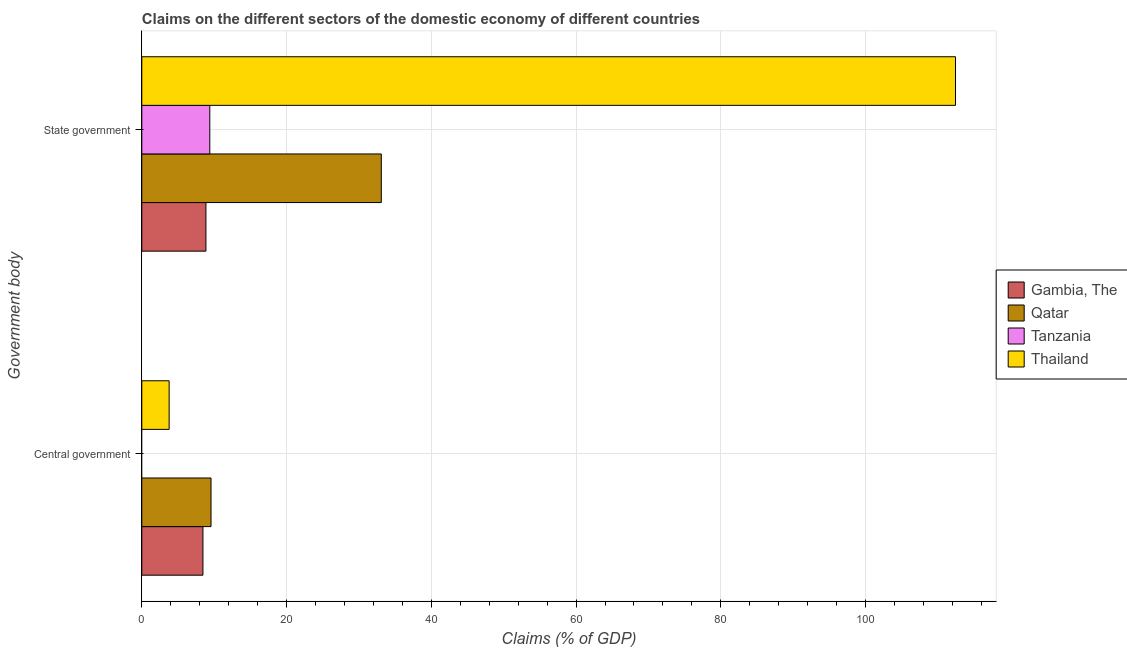Are the number of bars per tick equal to the number of legend labels?
Keep it short and to the point. No. How many bars are there on the 1st tick from the top?
Your answer should be compact. 4. What is the label of the 1st group of bars from the top?
Keep it short and to the point. State government. What is the claims on state government in Tanzania?
Provide a short and direct response. 9.4. Across all countries, what is the maximum claims on central government?
Make the answer very short. 9.56. Across all countries, what is the minimum claims on state government?
Ensure brevity in your answer.  8.86. In which country was the claims on state government maximum?
Your answer should be compact. Thailand. What is the total claims on central government in the graph?
Offer a very short reply. 21.79. What is the difference between the claims on state government in Tanzania and that in Qatar?
Your response must be concise. -23.7. What is the difference between the claims on state government in Tanzania and the claims on central government in Thailand?
Keep it short and to the point. 5.62. What is the average claims on central government per country?
Your answer should be compact. 5.45. What is the difference between the claims on state government and claims on central government in Thailand?
Offer a terse response. 108.65. In how many countries, is the claims on central government greater than 92 %?
Give a very brief answer. 0. What is the ratio of the claims on state government in Gambia, The to that in Qatar?
Give a very brief answer. 0.27. Is the claims on central government in Gambia, The less than that in Thailand?
Provide a succinct answer. No. In how many countries, is the claims on state government greater than the average claims on state government taken over all countries?
Provide a succinct answer. 1. Does the graph contain grids?
Offer a very short reply. Yes. How are the legend labels stacked?
Give a very brief answer. Vertical. What is the title of the graph?
Offer a terse response. Claims on the different sectors of the domestic economy of different countries. What is the label or title of the X-axis?
Your response must be concise. Claims (% of GDP). What is the label or title of the Y-axis?
Provide a succinct answer. Government body. What is the Claims (% of GDP) in Gambia, The in Central government?
Make the answer very short. 8.45. What is the Claims (% of GDP) in Qatar in Central government?
Your answer should be compact. 9.56. What is the Claims (% of GDP) of Thailand in Central government?
Your answer should be very brief. 3.78. What is the Claims (% of GDP) of Gambia, The in State government?
Your response must be concise. 8.86. What is the Claims (% of GDP) in Qatar in State government?
Your answer should be compact. 33.09. What is the Claims (% of GDP) in Tanzania in State government?
Your answer should be very brief. 9.4. What is the Claims (% of GDP) in Thailand in State government?
Give a very brief answer. 112.43. Across all Government body, what is the maximum Claims (% of GDP) of Gambia, The?
Your answer should be very brief. 8.86. Across all Government body, what is the maximum Claims (% of GDP) in Qatar?
Give a very brief answer. 33.09. Across all Government body, what is the maximum Claims (% of GDP) in Tanzania?
Provide a short and direct response. 9.4. Across all Government body, what is the maximum Claims (% of GDP) in Thailand?
Offer a terse response. 112.43. Across all Government body, what is the minimum Claims (% of GDP) of Gambia, The?
Your answer should be compact. 8.45. Across all Government body, what is the minimum Claims (% of GDP) of Qatar?
Offer a very short reply. 9.56. Across all Government body, what is the minimum Claims (% of GDP) in Thailand?
Offer a very short reply. 3.78. What is the total Claims (% of GDP) of Gambia, The in the graph?
Make the answer very short. 17.31. What is the total Claims (% of GDP) in Qatar in the graph?
Your answer should be very brief. 42.65. What is the total Claims (% of GDP) of Tanzania in the graph?
Offer a terse response. 9.4. What is the total Claims (% of GDP) in Thailand in the graph?
Make the answer very short. 116.21. What is the difference between the Claims (% of GDP) of Gambia, The in Central government and that in State government?
Your answer should be very brief. -0.41. What is the difference between the Claims (% of GDP) in Qatar in Central government and that in State government?
Keep it short and to the point. -23.53. What is the difference between the Claims (% of GDP) in Thailand in Central government and that in State government?
Your answer should be very brief. -108.65. What is the difference between the Claims (% of GDP) of Gambia, The in Central government and the Claims (% of GDP) of Qatar in State government?
Provide a succinct answer. -24.64. What is the difference between the Claims (% of GDP) in Gambia, The in Central government and the Claims (% of GDP) in Tanzania in State government?
Provide a succinct answer. -0.95. What is the difference between the Claims (% of GDP) in Gambia, The in Central government and the Claims (% of GDP) in Thailand in State government?
Your response must be concise. -103.98. What is the difference between the Claims (% of GDP) in Qatar in Central government and the Claims (% of GDP) in Tanzania in State government?
Your response must be concise. 0.17. What is the difference between the Claims (% of GDP) in Qatar in Central government and the Claims (% of GDP) in Thailand in State government?
Your answer should be very brief. -102.86. What is the average Claims (% of GDP) in Gambia, The per Government body?
Provide a succinct answer. 8.65. What is the average Claims (% of GDP) in Qatar per Government body?
Your answer should be very brief. 21.33. What is the average Claims (% of GDP) in Tanzania per Government body?
Give a very brief answer. 4.7. What is the average Claims (% of GDP) in Thailand per Government body?
Give a very brief answer. 58.1. What is the difference between the Claims (% of GDP) of Gambia, The and Claims (% of GDP) of Qatar in Central government?
Your response must be concise. -1.11. What is the difference between the Claims (% of GDP) in Gambia, The and Claims (% of GDP) in Thailand in Central government?
Keep it short and to the point. 4.67. What is the difference between the Claims (% of GDP) of Qatar and Claims (% of GDP) of Thailand in Central government?
Your answer should be compact. 5.78. What is the difference between the Claims (% of GDP) in Gambia, The and Claims (% of GDP) in Qatar in State government?
Give a very brief answer. -24.23. What is the difference between the Claims (% of GDP) of Gambia, The and Claims (% of GDP) of Tanzania in State government?
Your answer should be compact. -0.53. What is the difference between the Claims (% of GDP) in Gambia, The and Claims (% of GDP) in Thailand in State government?
Provide a short and direct response. -103.57. What is the difference between the Claims (% of GDP) in Qatar and Claims (% of GDP) in Tanzania in State government?
Provide a succinct answer. 23.7. What is the difference between the Claims (% of GDP) of Qatar and Claims (% of GDP) of Thailand in State government?
Keep it short and to the point. -79.34. What is the difference between the Claims (% of GDP) in Tanzania and Claims (% of GDP) in Thailand in State government?
Provide a short and direct response. -103.03. What is the ratio of the Claims (% of GDP) in Gambia, The in Central government to that in State government?
Provide a succinct answer. 0.95. What is the ratio of the Claims (% of GDP) in Qatar in Central government to that in State government?
Ensure brevity in your answer.  0.29. What is the ratio of the Claims (% of GDP) of Thailand in Central government to that in State government?
Keep it short and to the point. 0.03. What is the difference between the highest and the second highest Claims (% of GDP) in Gambia, The?
Your answer should be very brief. 0.41. What is the difference between the highest and the second highest Claims (% of GDP) of Qatar?
Your answer should be very brief. 23.53. What is the difference between the highest and the second highest Claims (% of GDP) of Thailand?
Offer a terse response. 108.65. What is the difference between the highest and the lowest Claims (% of GDP) in Gambia, The?
Make the answer very short. 0.41. What is the difference between the highest and the lowest Claims (% of GDP) of Qatar?
Make the answer very short. 23.53. What is the difference between the highest and the lowest Claims (% of GDP) of Tanzania?
Your answer should be very brief. 9.4. What is the difference between the highest and the lowest Claims (% of GDP) in Thailand?
Your answer should be very brief. 108.65. 